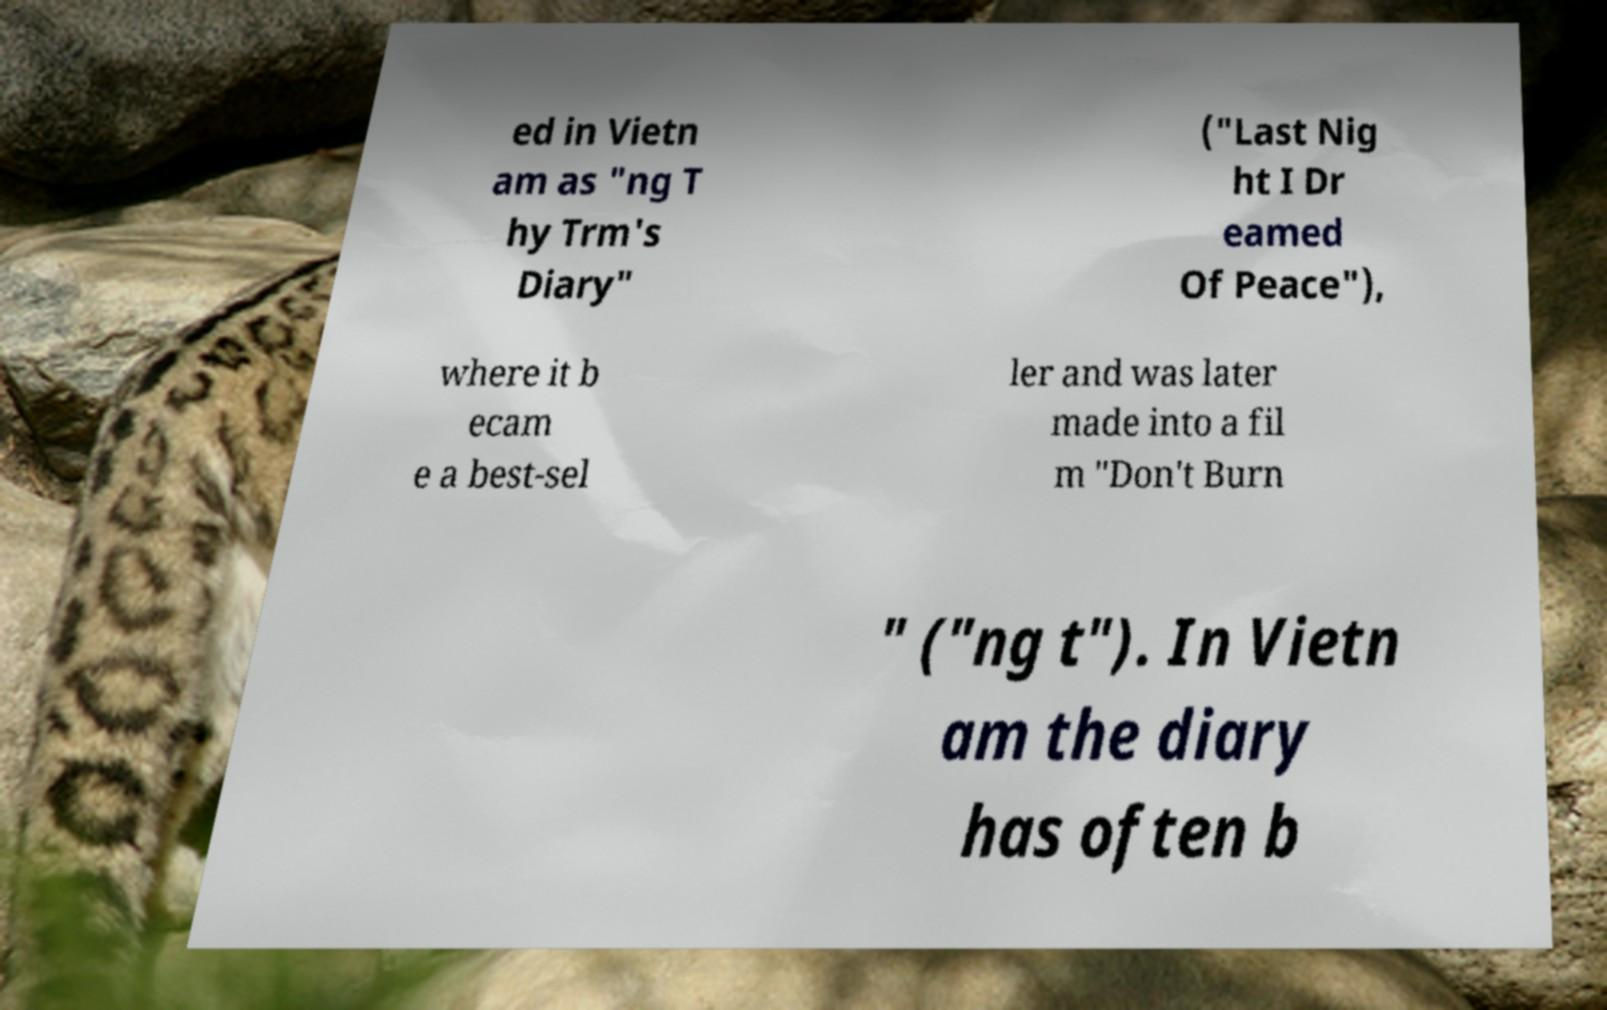Can you accurately transcribe the text from the provided image for me? ed in Vietn am as "ng T hy Trm's Diary" ("Last Nig ht I Dr eamed Of Peace"), where it b ecam e a best-sel ler and was later made into a fil m "Don't Burn " ("ng t"). In Vietn am the diary has often b 